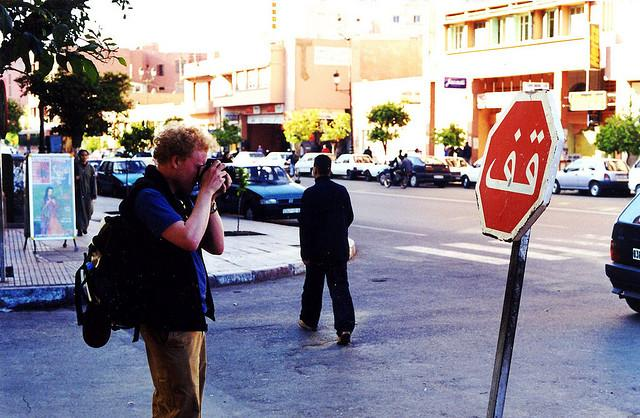What country is this?

Choices:
A) india
B) canada
C) ireland
D) mexico india 